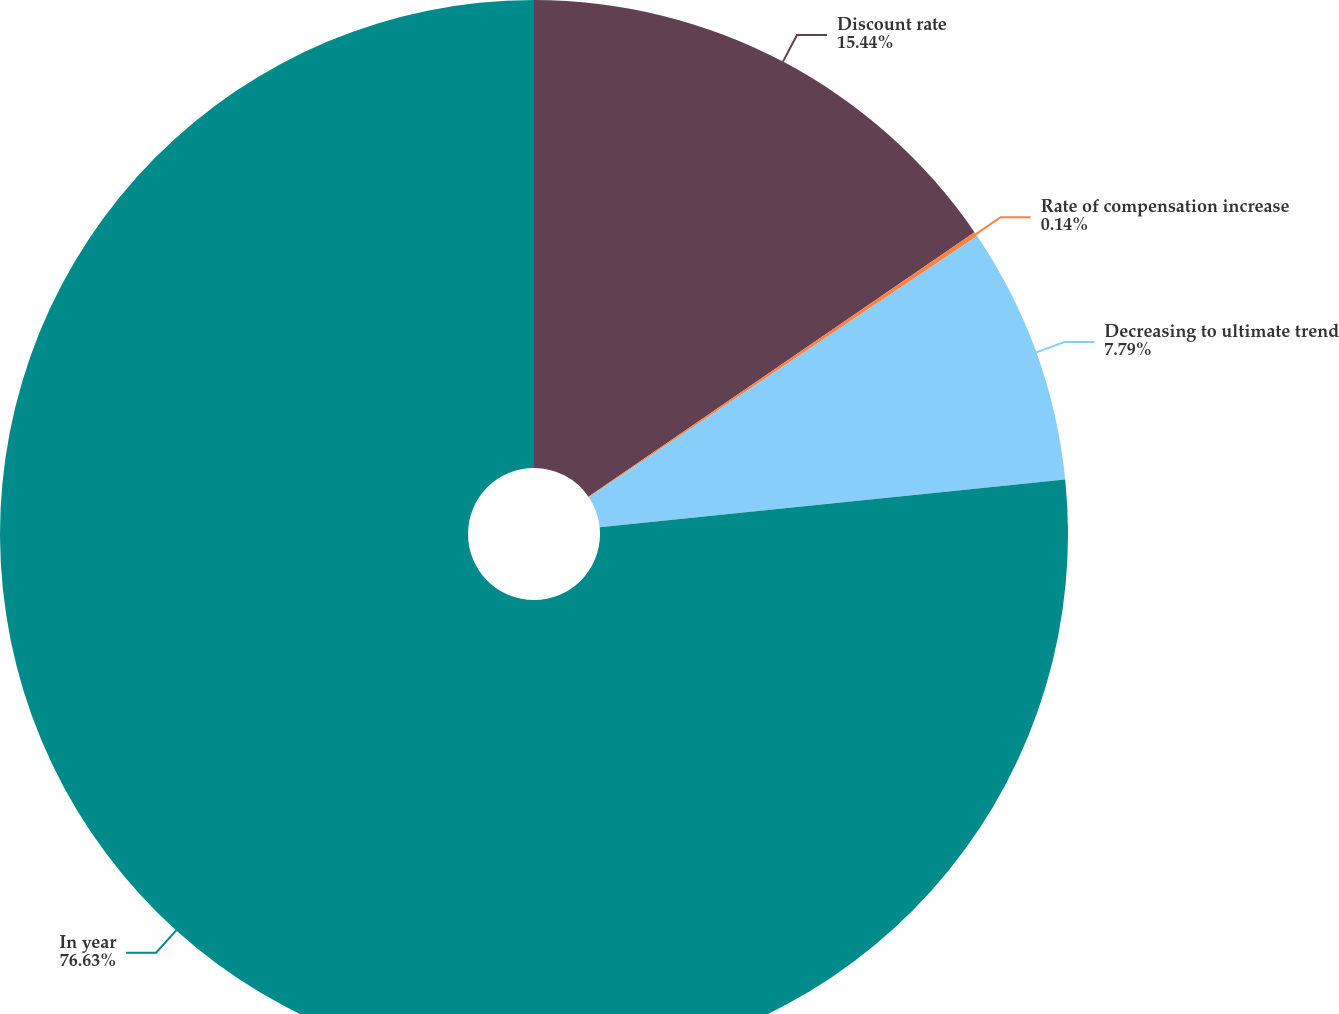Convert chart to OTSL. <chart><loc_0><loc_0><loc_500><loc_500><pie_chart><fcel>Discount rate<fcel>Rate of compensation increase<fcel>Decreasing to ultimate trend<fcel>In year<nl><fcel>15.44%<fcel>0.14%<fcel>7.79%<fcel>76.63%<nl></chart> 